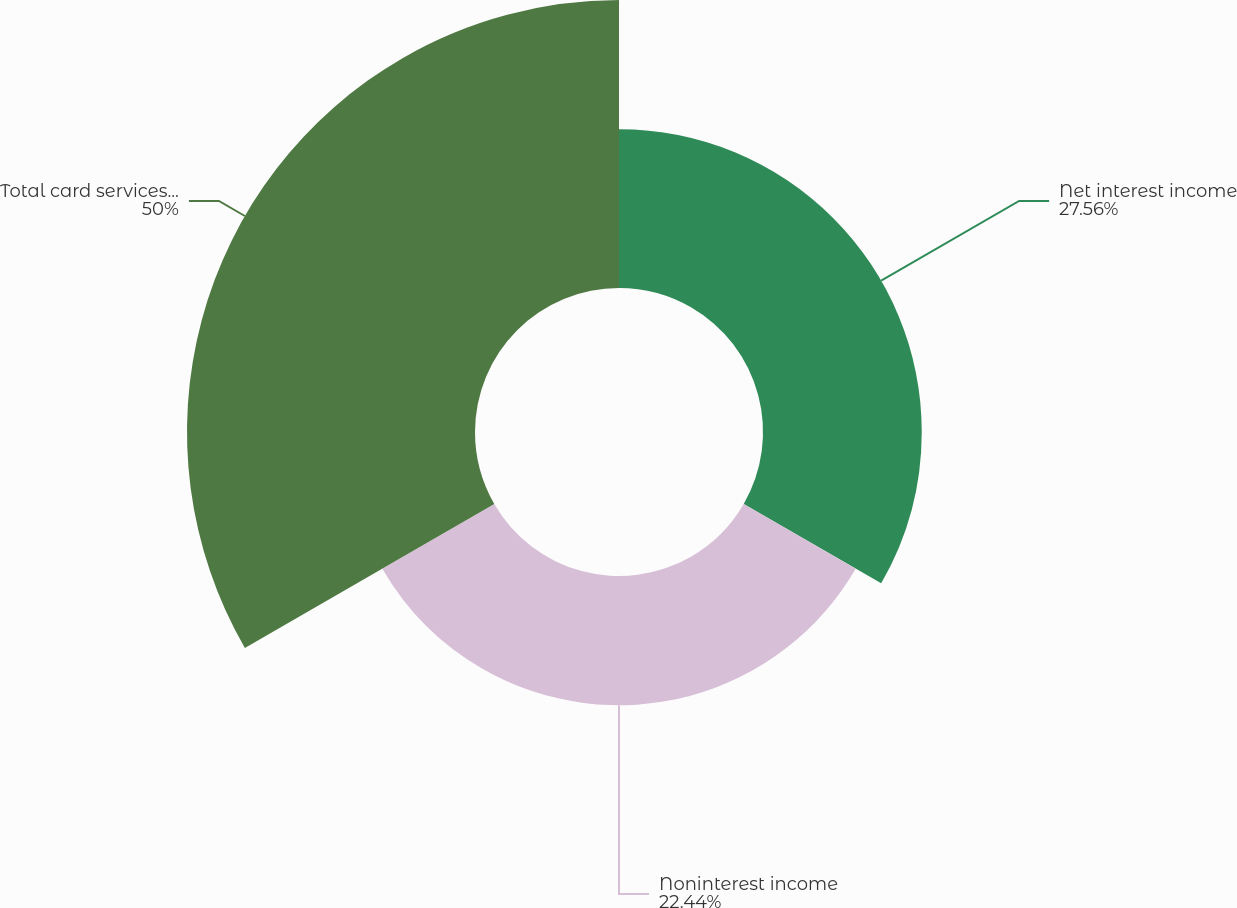Convert chart. <chart><loc_0><loc_0><loc_500><loc_500><pie_chart><fcel>Net interest income<fcel>Noninterest income<fcel>Total card services revenue<nl><fcel>27.56%<fcel>22.44%<fcel>50.0%<nl></chart> 